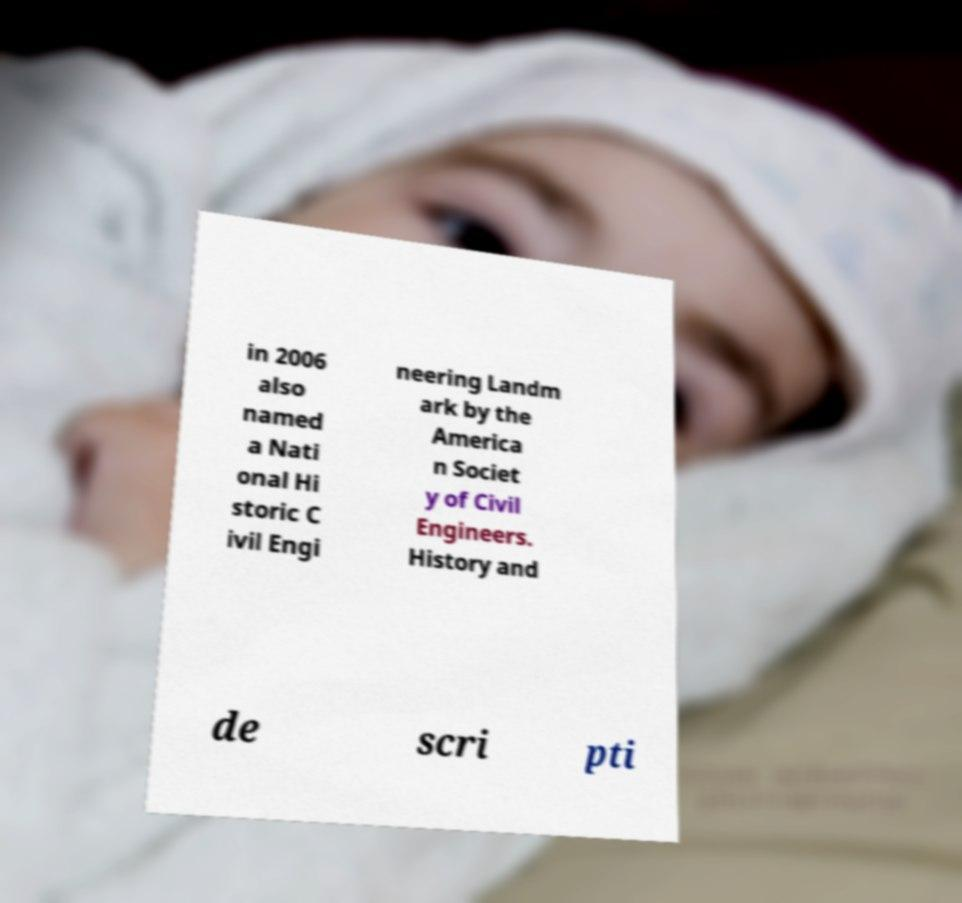Please read and relay the text visible in this image. What does it say? in 2006 also named a Nati onal Hi storic C ivil Engi neering Landm ark by the America n Societ y of Civil Engineers. History and de scri pti 